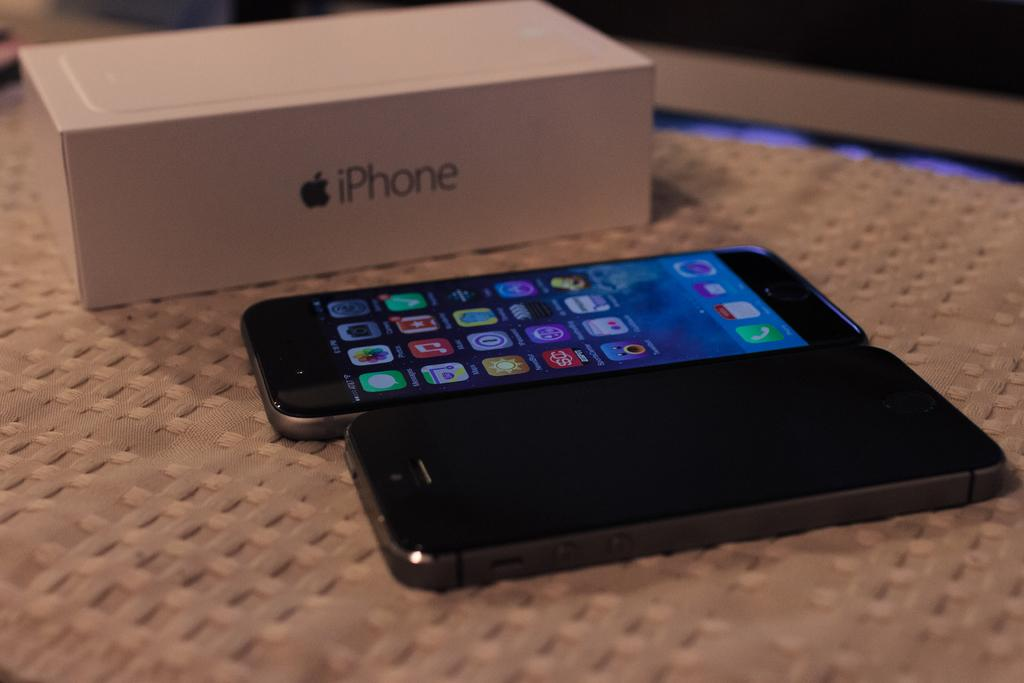<image>
Write a terse but informative summary of the picture. Two iphones lay side by side by an iphone box. 